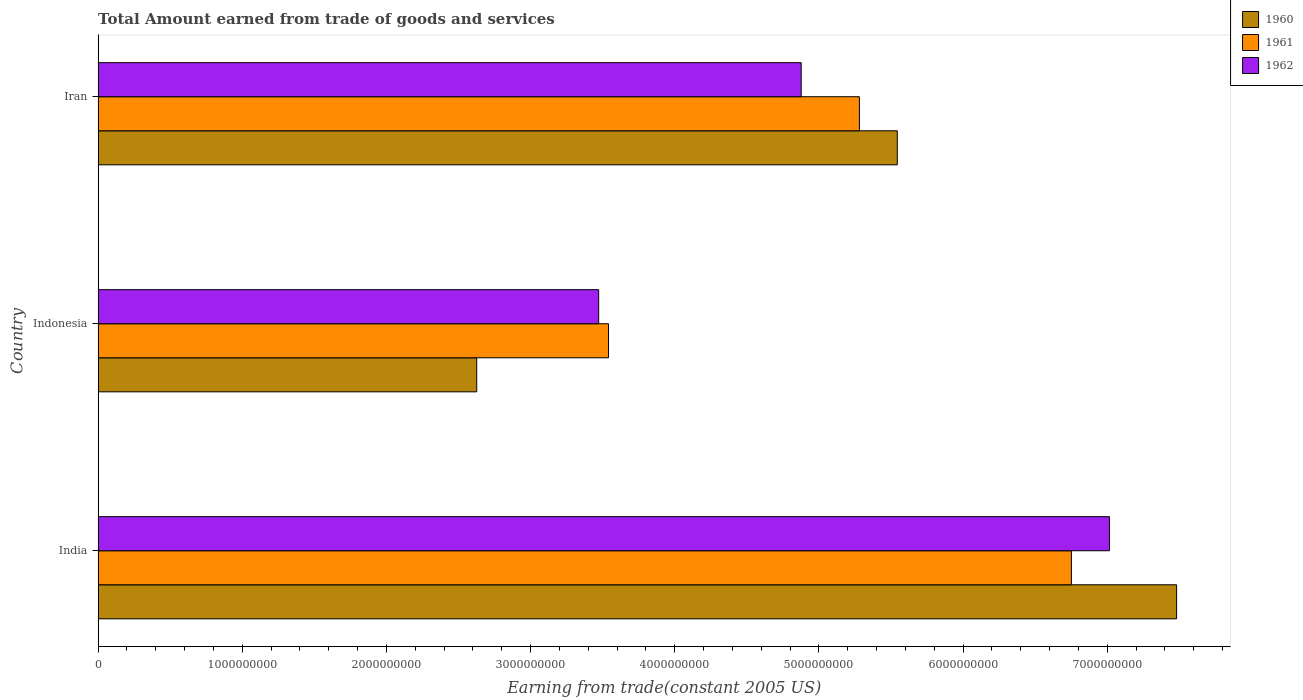Are the number of bars per tick equal to the number of legend labels?
Offer a terse response. Yes. How many bars are there on the 2nd tick from the bottom?
Your answer should be compact. 3. What is the label of the 1st group of bars from the top?
Provide a short and direct response. Iran. In how many cases, is the number of bars for a given country not equal to the number of legend labels?
Ensure brevity in your answer.  0. What is the total amount earned by trading goods and services in 1960 in India?
Ensure brevity in your answer.  7.48e+09. Across all countries, what is the maximum total amount earned by trading goods and services in 1962?
Provide a succinct answer. 7.02e+09. Across all countries, what is the minimum total amount earned by trading goods and services in 1962?
Provide a succinct answer. 3.47e+09. What is the total total amount earned by trading goods and services in 1960 in the graph?
Your answer should be compact. 1.57e+1. What is the difference between the total amount earned by trading goods and services in 1961 in India and that in Indonesia?
Provide a short and direct response. 3.21e+09. What is the difference between the total amount earned by trading goods and services in 1961 in India and the total amount earned by trading goods and services in 1962 in Indonesia?
Your answer should be very brief. 3.28e+09. What is the average total amount earned by trading goods and services in 1962 per country?
Your response must be concise. 5.12e+09. What is the difference between the total amount earned by trading goods and services in 1961 and total amount earned by trading goods and services in 1962 in India?
Your response must be concise. -2.64e+08. What is the ratio of the total amount earned by trading goods and services in 1962 in India to that in Indonesia?
Provide a succinct answer. 2.02. Is the total amount earned by trading goods and services in 1962 in India less than that in Iran?
Provide a succinct answer. No. What is the difference between the highest and the second highest total amount earned by trading goods and services in 1961?
Ensure brevity in your answer.  1.47e+09. What is the difference between the highest and the lowest total amount earned by trading goods and services in 1961?
Offer a very short reply. 3.21e+09. In how many countries, is the total amount earned by trading goods and services in 1961 greater than the average total amount earned by trading goods and services in 1961 taken over all countries?
Your answer should be very brief. 2. What does the 2nd bar from the top in Iran represents?
Offer a terse response. 1961. How many bars are there?
Your response must be concise. 9. Are all the bars in the graph horizontal?
Offer a terse response. Yes. How many countries are there in the graph?
Your response must be concise. 3. What is the difference between two consecutive major ticks on the X-axis?
Ensure brevity in your answer.  1.00e+09. Does the graph contain grids?
Your answer should be compact. No. Where does the legend appear in the graph?
Ensure brevity in your answer.  Top right. What is the title of the graph?
Your answer should be very brief. Total Amount earned from trade of goods and services. Does "2012" appear as one of the legend labels in the graph?
Ensure brevity in your answer.  No. What is the label or title of the X-axis?
Keep it short and to the point. Earning from trade(constant 2005 US). What is the Earning from trade(constant 2005 US) of 1960 in India?
Keep it short and to the point. 7.48e+09. What is the Earning from trade(constant 2005 US) in 1961 in India?
Keep it short and to the point. 6.75e+09. What is the Earning from trade(constant 2005 US) in 1962 in India?
Your answer should be compact. 7.02e+09. What is the Earning from trade(constant 2005 US) in 1960 in Indonesia?
Your answer should be very brief. 2.63e+09. What is the Earning from trade(constant 2005 US) in 1961 in Indonesia?
Provide a succinct answer. 3.54e+09. What is the Earning from trade(constant 2005 US) in 1962 in Indonesia?
Keep it short and to the point. 3.47e+09. What is the Earning from trade(constant 2005 US) of 1960 in Iran?
Your response must be concise. 5.54e+09. What is the Earning from trade(constant 2005 US) of 1961 in Iran?
Give a very brief answer. 5.28e+09. What is the Earning from trade(constant 2005 US) in 1962 in Iran?
Make the answer very short. 4.88e+09. Across all countries, what is the maximum Earning from trade(constant 2005 US) of 1960?
Your answer should be very brief. 7.48e+09. Across all countries, what is the maximum Earning from trade(constant 2005 US) in 1961?
Give a very brief answer. 6.75e+09. Across all countries, what is the maximum Earning from trade(constant 2005 US) in 1962?
Your answer should be very brief. 7.02e+09. Across all countries, what is the minimum Earning from trade(constant 2005 US) of 1960?
Offer a very short reply. 2.63e+09. Across all countries, what is the minimum Earning from trade(constant 2005 US) of 1961?
Keep it short and to the point. 3.54e+09. Across all countries, what is the minimum Earning from trade(constant 2005 US) in 1962?
Your answer should be compact. 3.47e+09. What is the total Earning from trade(constant 2005 US) of 1960 in the graph?
Provide a succinct answer. 1.57e+1. What is the total Earning from trade(constant 2005 US) of 1961 in the graph?
Keep it short and to the point. 1.56e+1. What is the total Earning from trade(constant 2005 US) in 1962 in the graph?
Offer a terse response. 1.54e+1. What is the difference between the Earning from trade(constant 2005 US) in 1960 in India and that in Indonesia?
Keep it short and to the point. 4.85e+09. What is the difference between the Earning from trade(constant 2005 US) in 1961 in India and that in Indonesia?
Your answer should be compact. 3.21e+09. What is the difference between the Earning from trade(constant 2005 US) of 1962 in India and that in Indonesia?
Keep it short and to the point. 3.54e+09. What is the difference between the Earning from trade(constant 2005 US) of 1960 in India and that in Iran?
Offer a terse response. 1.94e+09. What is the difference between the Earning from trade(constant 2005 US) in 1961 in India and that in Iran?
Your answer should be compact. 1.47e+09. What is the difference between the Earning from trade(constant 2005 US) in 1962 in India and that in Iran?
Offer a very short reply. 2.14e+09. What is the difference between the Earning from trade(constant 2005 US) in 1960 in Indonesia and that in Iran?
Ensure brevity in your answer.  -2.92e+09. What is the difference between the Earning from trade(constant 2005 US) of 1961 in Indonesia and that in Iran?
Make the answer very short. -1.74e+09. What is the difference between the Earning from trade(constant 2005 US) in 1962 in Indonesia and that in Iran?
Keep it short and to the point. -1.40e+09. What is the difference between the Earning from trade(constant 2005 US) in 1960 in India and the Earning from trade(constant 2005 US) in 1961 in Indonesia?
Make the answer very short. 3.94e+09. What is the difference between the Earning from trade(constant 2005 US) in 1960 in India and the Earning from trade(constant 2005 US) in 1962 in Indonesia?
Give a very brief answer. 4.01e+09. What is the difference between the Earning from trade(constant 2005 US) of 1961 in India and the Earning from trade(constant 2005 US) of 1962 in Indonesia?
Keep it short and to the point. 3.28e+09. What is the difference between the Earning from trade(constant 2005 US) of 1960 in India and the Earning from trade(constant 2005 US) of 1961 in Iran?
Make the answer very short. 2.20e+09. What is the difference between the Earning from trade(constant 2005 US) of 1960 in India and the Earning from trade(constant 2005 US) of 1962 in Iran?
Your answer should be compact. 2.60e+09. What is the difference between the Earning from trade(constant 2005 US) of 1961 in India and the Earning from trade(constant 2005 US) of 1962 in Iran?
Your answer should be compact. 1.87e+09. What is the difference between the Earning from trade(constant 2005 US) in 1960 in Indonesia and the Earning from trade(constant 2005 US) in 1961 in Iran?
Provide a succinct answer. -2.65e+09. What is the difference between the Earning from trade(constant 2005 US) of 1960 in Indonesia and the Earning from trade(constant 2005 US) of 1962 in Iran?
Give a very brief answer. -2.25e+09. What is the difference between the Earning from trade(constant 2005 US) of 1961 in Indonesia and the Earning from trade(constant 2005 US) of 1962 in Iran?
Your answer should be compact. -1.34e+09. What is the average Earning from trade(constant 2005 US) of 1960 per country?
Offer a very short reply. 5.22e+09. What is the average Earning from trade(constant 2005 US) in 1961 per country?
Offer a very short reply. 5.19e+09. What is the average Earning from trade(constant 2005 US) of 1962 per country?
Give a very brief answer. 5.12e+09. What is the difference between the Earning from trade(constant 2005 US) in 1960 and Earning from trade(constant 2005 US) in 1961 in India?
Ensure brevity in your answer.  7.30e+08. What is the difference between the Earning from trade(constant 2005 US) in 1960 and Earning from trade(constant 2005 US) in 1962 in India?
Provide a succinct answer. 4.66e+08. What is the difference between the Earning from trade(constant 2005 US) in 1961 and Earning from trade(constant 2005 US) in 1962 in India?
Make the answer very short. -2.64e+08. What is the difference between the Earning from trade(constant 2005 US) in 1960 and Earning from trade(constant 2005 US) in 1961 in Indonesia?
Your answer should be very brief. -9.14e+08. What is the difference between the Earning from trade(constant 2005 US) in 1960 and Earning from trade(constant 2005 US) in 1962 in Indonesia?
Make the answer very short. -8.46e+08. What is the difference between the Earning from trade(constant 2005 US) in 1961 and Earning from trade(constant 2005 US) in 1962 in Indonesia?
Your answer should be compact. 6.82e+07. What is the difference between the Earning from trade(constant 2005 US) of 1960 and Earning from trade(constant 2005 US) of 1961 in Iran?
Your answer should be compact. 2.63e+08. What is the difference between the Earning from trade(constant 2005 US) in 1960 and Earning from trade(constant 2005 US) in 1962 in Iran?
Your answer should be very brief. 6.67e+08. What is the difference between the Earning from trade(constant 2005 US) in 1961 and Earning from trade(constant 2005 US) in 1962 in Iran?
Provide a short and direct response. 4.04e+08. What is the ratio of the Earning from trade(constant 2005 US) of 1960 in India to that in Indonesia?
Keep it short and to the point. 2.85. What is the ratio of the Earning from trade(constant 2005 US) in 1961 in India to that in Indonesia?
Provide a succinct answer. 1.91. What is the ratio of the Earning from trade(constant 2005 US) of 1962 in India to that in Indonesia?
Make the answer very short. 2.02. What is the ratio of the Earning from trade(constant 2005 US) in 1960 in India to that in Iran?
Provide a short and direct response. 1.35. What is the ratio of the Earning from trade(constant 2005 US) of 1961 in India to that in Iran?
Offer a very short reply. 1.28. What is the ratio of the Earning from trade(constant 2005 US) of 1962 in India to that in Iran?
Offer a very short reply. 1.44. What is the ratio of the Earning from trade(constant 2005 US) in 1960 in Indonesia to that in Iran?
Keep it short and to the point. 0.47. What is the ratio of the Earning from trade(constant 2005 US) of 1961 in Indonesia to that in Iran?
Give a very brief answer. 0.67. What is the ratio of the Earning from trade(constant 2005 US) in 1962 in Indonesia to that in Iran?
Give a very brief answer. 0.71. What is the difference between the highest and the second highest Earning from trade(constant 2005 US) in 1960?
Keep it short and to the point. 1.94e+09. What is the difference between the highest and the second highest Earning from trade(constant 2005 US) of 1961?
Your answer should be compact. 1.47e+09. What is the difference between the highest and the second highest Earning from trade(constant 2005 US) in 1962?
Offer a terse response. 2.14e+09. What is the difference between the highest and the lowest Earning from trade(constant 2005 US) of 1960?
Offer a terse response. 4.85e+09. What is the difference between the highest and the lowest Earning from trade(constant 2005 US) of 1961?
Offer a terse response. 3.21e+09. What is the difference between the highest and the lowest Earning from trade(constant 2005 US) of 1962?
Offer a very short reply. 3.54e+09. 